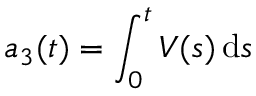Convert formula to latex. <formula><loc_0><loc_0><loc_500><loc_500>a _ { 3 } ( t ) = \int _ { 0 } ^ { t } V ( s ) \, d s</formula> 